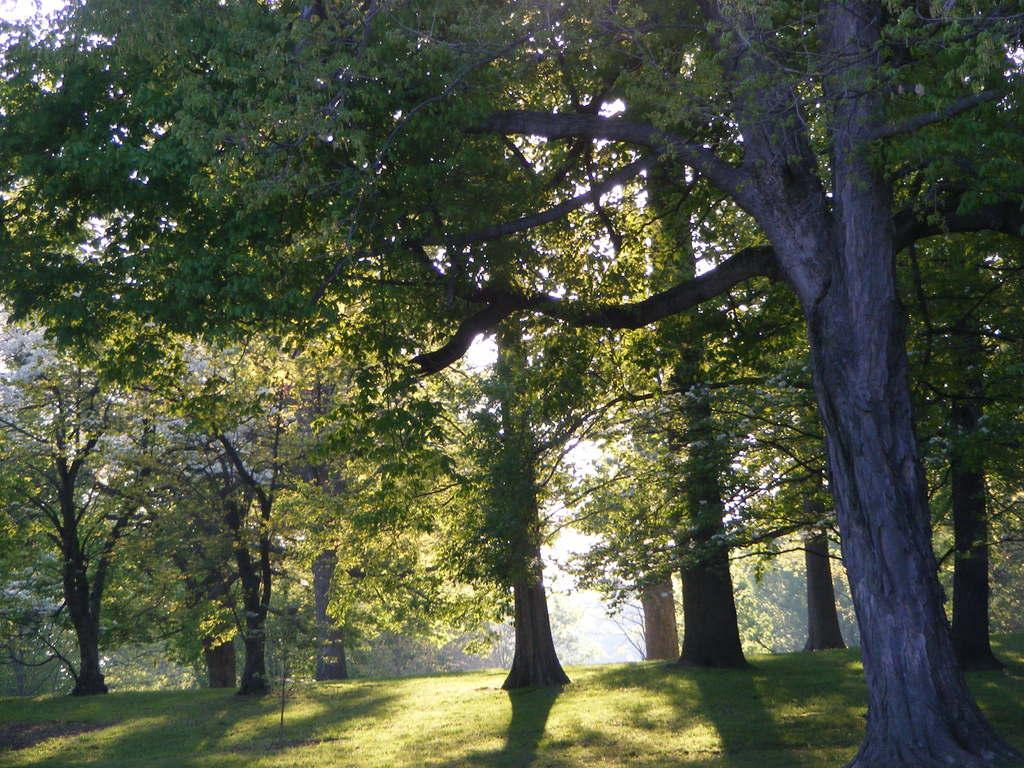What type of vegetation can be seen in the image? There are trees in the image. What part of the natural environment is visible at the bottom of the image? The ground is visible at the bottom of the image. What type of prose is being recited by the mother in the image? There is no mother or prose present in the image; it only features trees and the ground. 